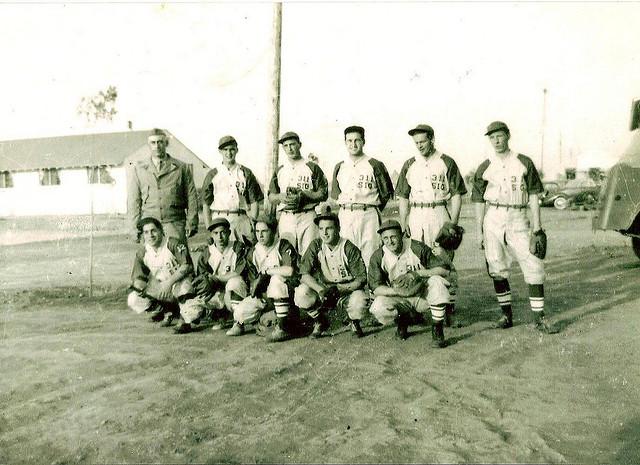What sport are they equipped for?
Give a very brief answer. Baseball. What number is on the yellow shirt?
Give a very brief answer. 311. How many guys are here?
Quick response, please. 11. What team are they playing for?
Quick response, please. Baseball. IS this a recent picture?
Concise answer only. No. Is this an army picture?
Be succinct. No. 